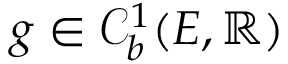<formula> <loc_0><loc_0><loc_500><loc_500>g \in \mathcal { C } _ { b } ^ { 1 } ( E , \mathbb { R } )</formula> 